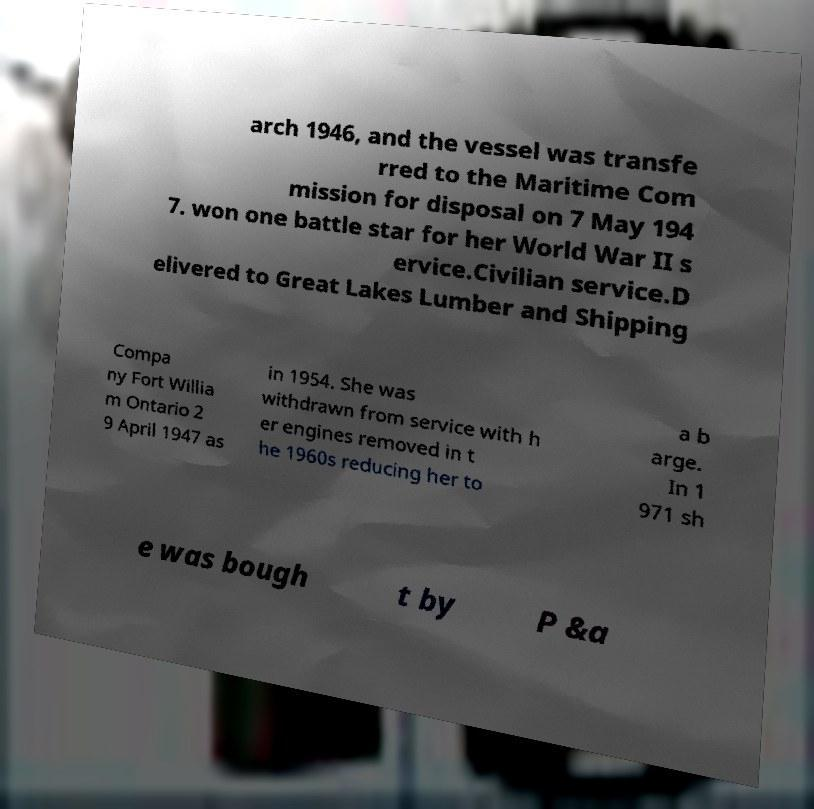Can you accurately transcribe the text from the provided image for me? arch 1946, and the vessel was transfe rred to the Maritime Com mission for disposal on 7 May 194 7. won one battle star for her World War II s ervice.Civilian service.D elivered to Great Lakes Lumber and Shipping Compa ny Fort Willia m Ontario 2 9 April 1947 as in 1954. She was withdrawn from service with h er engines removed in t he 1960s reducing her to a b arge. In 1 971 sh e was bough t by P &a 